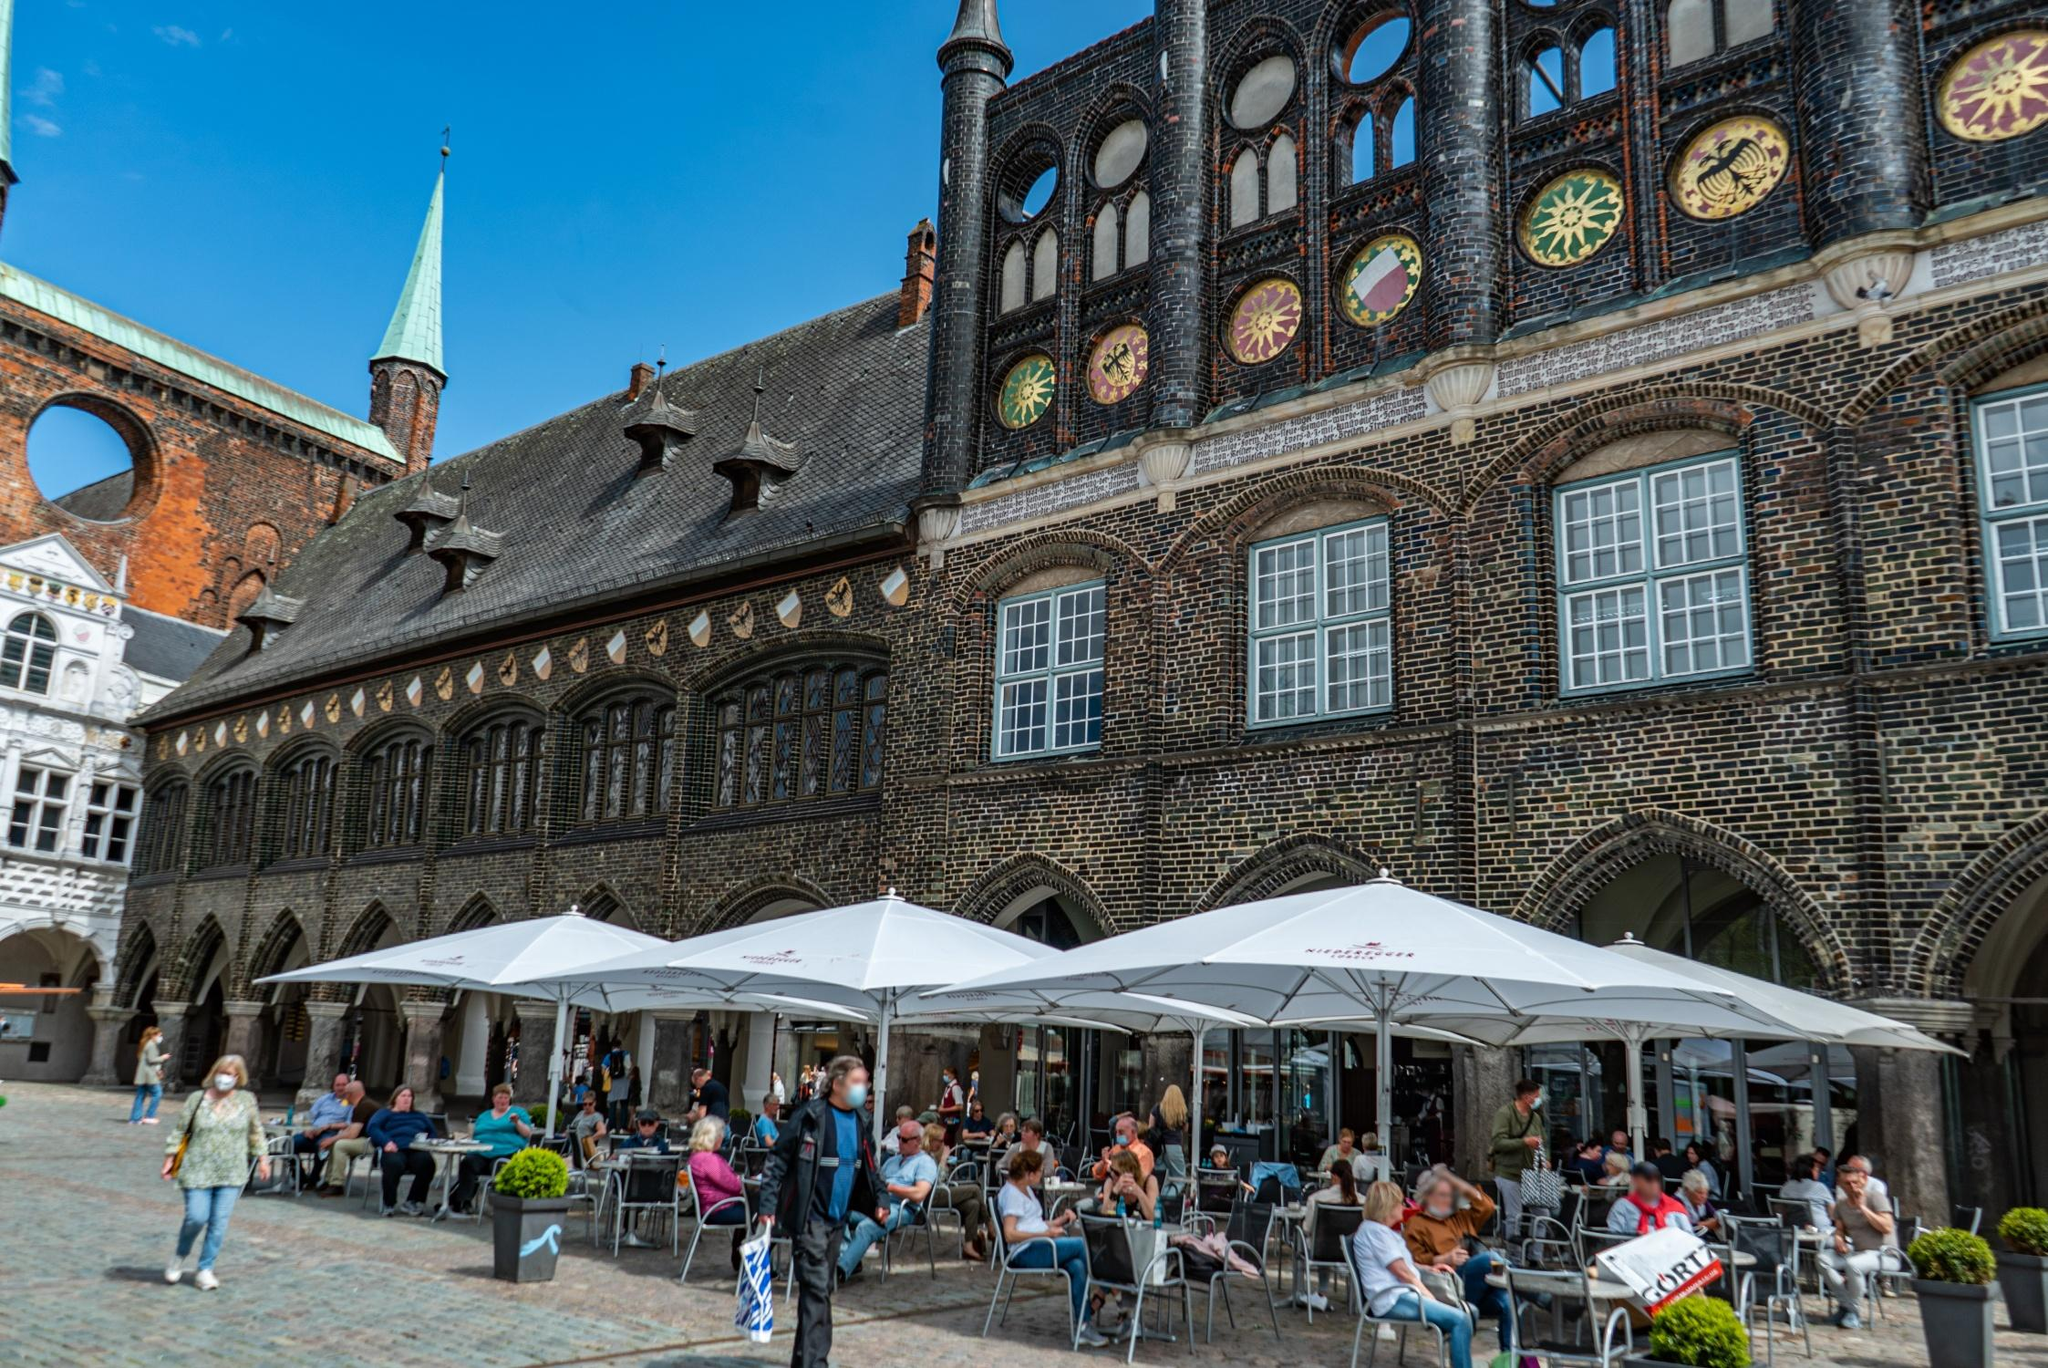What is the historical significance of the building in this image? The Lübeck Town Hall is one of the oldest and most significant town halls in Germany. Originating in the 13th century, it has served as the seat of the city’s council and witnessed numerous historical events. The building's unique Gothic architecture and the additions from the Renaissance period reflect Lübeck’s prominence during the Hanseatic League era. It stands as a testament to the city's rich mercantile past and its significant role in Northern Europe’s economic history. Can you describe any changes or restorations the town hall has undergone over the years? Over the centuries, the Lübeck Town Hall has undergone several changes and restorations reflecting the architectural styles and functional needs of different periods. Initially constructed in the 13th century, the building incorporated Gothic elements such as pointed arches and elaborate brickwork. In the 15th and 16th centuries, Renaissance features were added, including decorative facades and an intricate interior. During the Second World War, parts of the town hall were damaged, leading to post-war restorations aimed at preserving its historical integrity while making necessary repairs.  If the town hall could speak, what stories might it tell about Lübeck's history? If the Lübeck Town Hall could speak, it might recount tales of bustling mercantile meetings where traders from around Europe discussed commerce and politics during the Hanseatic League's heydays. It would tell of the pride and challenges faced by Lübeck as it became a leading Baltic port. The town hall might also share somber memories from the WWII era, when parts of it were damaged, reflecting the city's resilience. It could describe the joyous celebrations and solemn protests witnessed in the vibrant square outside. Overall, it would narrate a rich tapestry of Lübeck's journey through prosperity, conflict, and rejuvenation. 